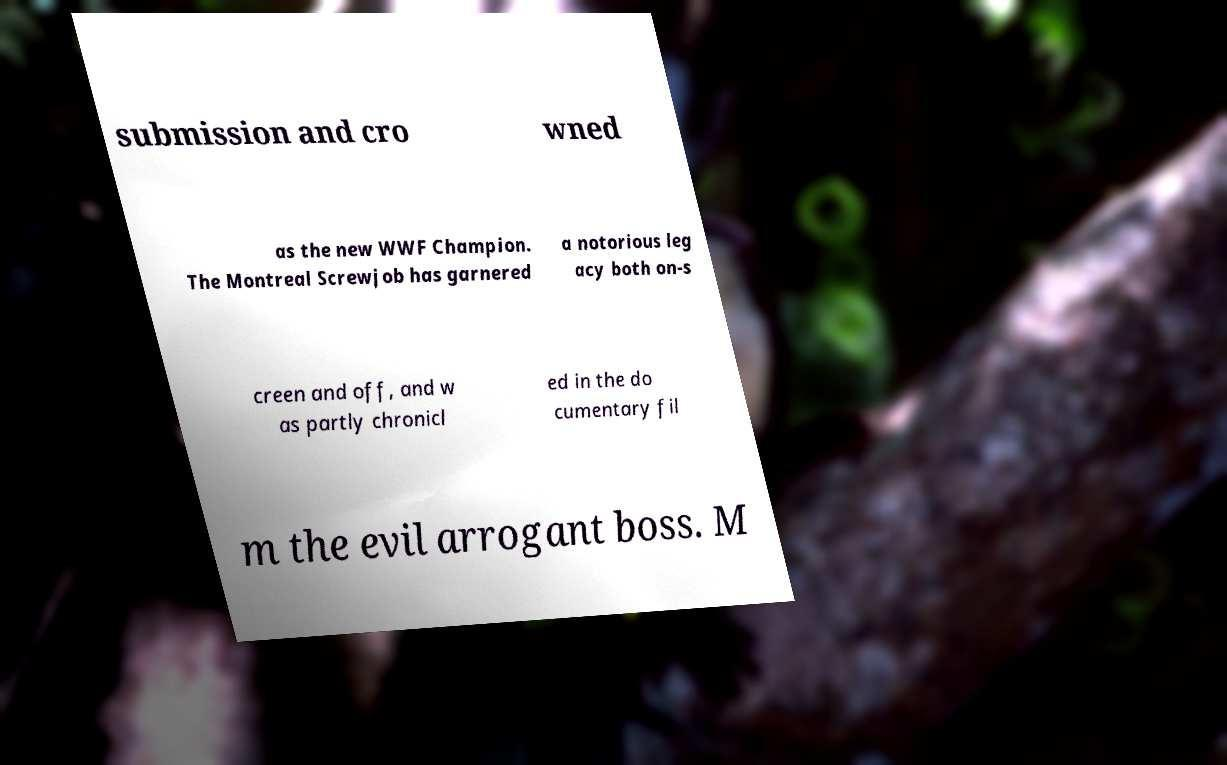There's text embedded in this image that I need extracted. Can you transcribe it verbatim? submission and cro wned as the new WWF Champion. The Montreal Screwjob has garnered a notorious leg acy both on-s creen and off, and w as partly chronicl ed in the do cumentary fil m the evil arrogant boss. M 